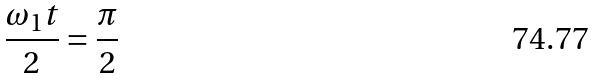Convert formula to latex. <formula><loc_0><loc_0><loc_500><loc_500>\frac { \omega _ { 1 } t } { 2 } = \frac { \pi } { 2 }</formula> 